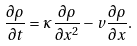Convert formula to latex. <formula><loc_0><loc_0><loc_500><loc_500>\frac { \partial \rho } { \partial t } = \kappa \frac { \partial \rho } { \partial x ^ { 2 } } - v \frac { \partial \rho } { \partial x } .</formula> 